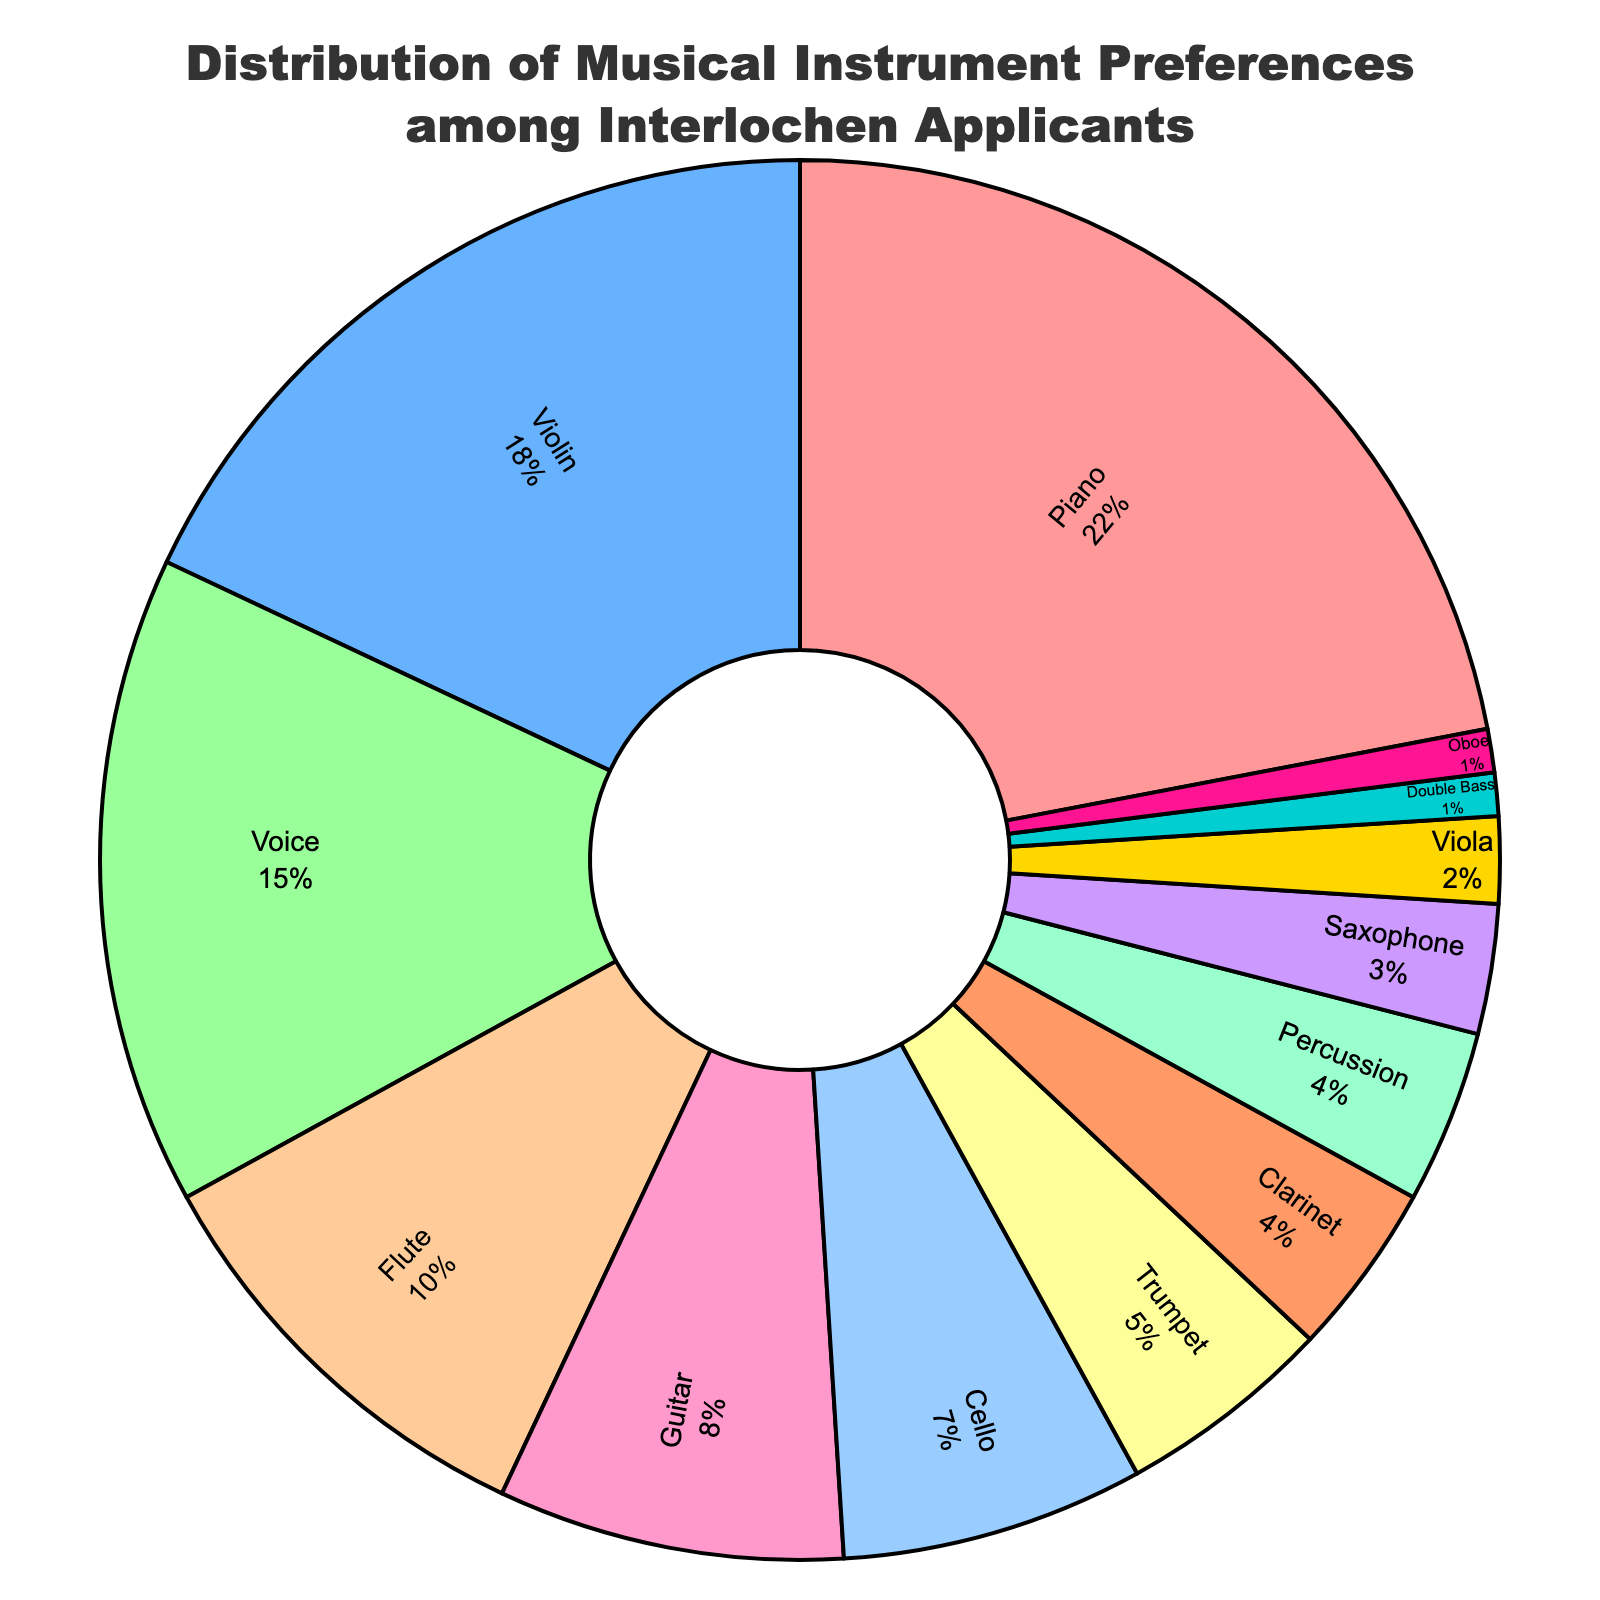Which instrument is the most popular among Interlochen applicants? The pie chart shows that the instrument with the largest percentage wedge is Piano.
Answer: Piano How many applicants prefer voice or guitar? Using the percentages from the pie chart, Voice = 15% and Guitar = 8%. Summing these gives 15% + 8% = 23%.
Answer: 23% What is the percentage difference between violin and cello preferences? From the pie chart, Violin = 18% and Cello = 7%. The difference is 18% - 7% = 11%.
Answer: 11% Which instrument has a higher preference percentage, flute or clarinet? The pie chart shows Flute at 10% and Clarinet at 4%. Since 10% > 4%, Flute has a higher preference.
Answer: Flute Among the instruments with less than 5% preference, how many different instruments are there? Percussion, Clarinet, Saxophone, Viola, Double Bass, and Oboe each have less than 5% preference. Counting these gives 6 instruments.
Answer: 6 What is the combined percentage of trumpet and saxophone preferences? From the pie chart, Trumpet = 5% and Saxophone = 3%. Their combined percentage is 5% + 3% = 8%.
Answer: 8% Is the number of applicants preferring piano greater than the combined number of those preferring voice and trumpet? Piano = 22%, Voice = 15%, and Trumpet = 5%. Combined, Voice and Trumpet = 15% + 5% = 20%. Since 22% (Piano) > 20%, the answer is yes.
Answer: Yes Which has a lower preference percentage, double bass or oboe? Both Double Bass and Oboe have 1% each, so their preference percentages are equal.
Answer: Equal What is the ratio of applicants who prefer piano to those who prefer viola? Piano = 22%, Viola = 2%. The ratio is 22% / 2% = 11:1.
Answer: 11:1 Add the percentages of all string instruments (piano not included). How much is that? Violin = 18%, Cello = 7%, Viola = 2%, Double Bass = 1%. Summing these gives 18% + 7% + 2% + 1% = 28%.
Answer: 28% 